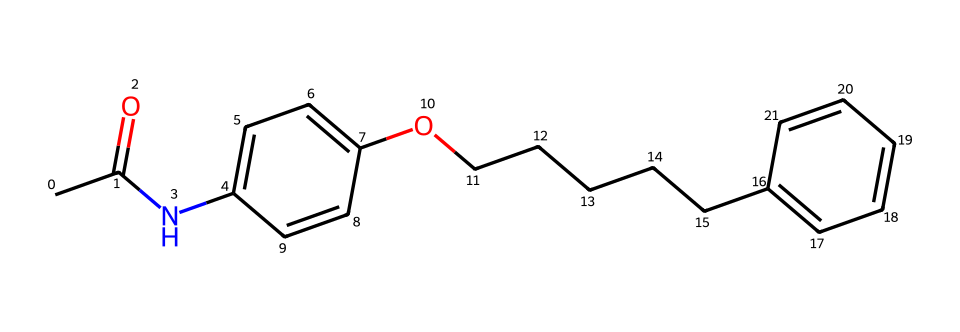What is the molecular formula of this compound? To determine the molecular formula, count the number of each type of atom in the SMILES representation. In this case, we identify the presence of carbon (C), hydrogen (H), nitrogen (N), and oxygen (O) atoms by analyzing the structure: there are 22 carbon atoms, 31 hydrogen atoms, 1 nitrogen atom, and 2 oxygen atoms, resulting in a molecular formula of C22H31N2O2.
Answer: C22H31N2O2 How many rings are present in this structure? By inspecting the structure represented in SMILES, observe the ring formations. There are two rings in the chemical structure as indicated by the numbered connections (C1 and C2), which create a cyclic configuration typical of the compound's aromatic characteristics.
Answer: 2 Which functional groups can be identified in the compound? Analyze the chemical structure for functional groups by looking for specific arrangements of atoms. Key functional groups are identified: an amine group (–NH), a hydroxyl group (–OH), and an ester group (–O–). These determine the chemical's reactivity and bonding capabilities.
Answer: amine, hydroxyl, ester What is the type of compound represented by the structure? This compound is synthesized from chili peppers, specifically identified as a vanilloid, a specific type of alkaloid. Its known properties make it characteristic of such compounds used primarily for their pungency and medicinal effects, reflecting its classification as a drug.
Answer: vanilloid What characteristic does this compound contribute to food, especially in tailgate dips? Capsaicin, the active component of this structure, is renowned for imparting heat or spiciness, which is a distinctive sensation that enhances flavor in a variety of food applications, particularly in dips served at social events like tailgates.
Answer: spiciness 